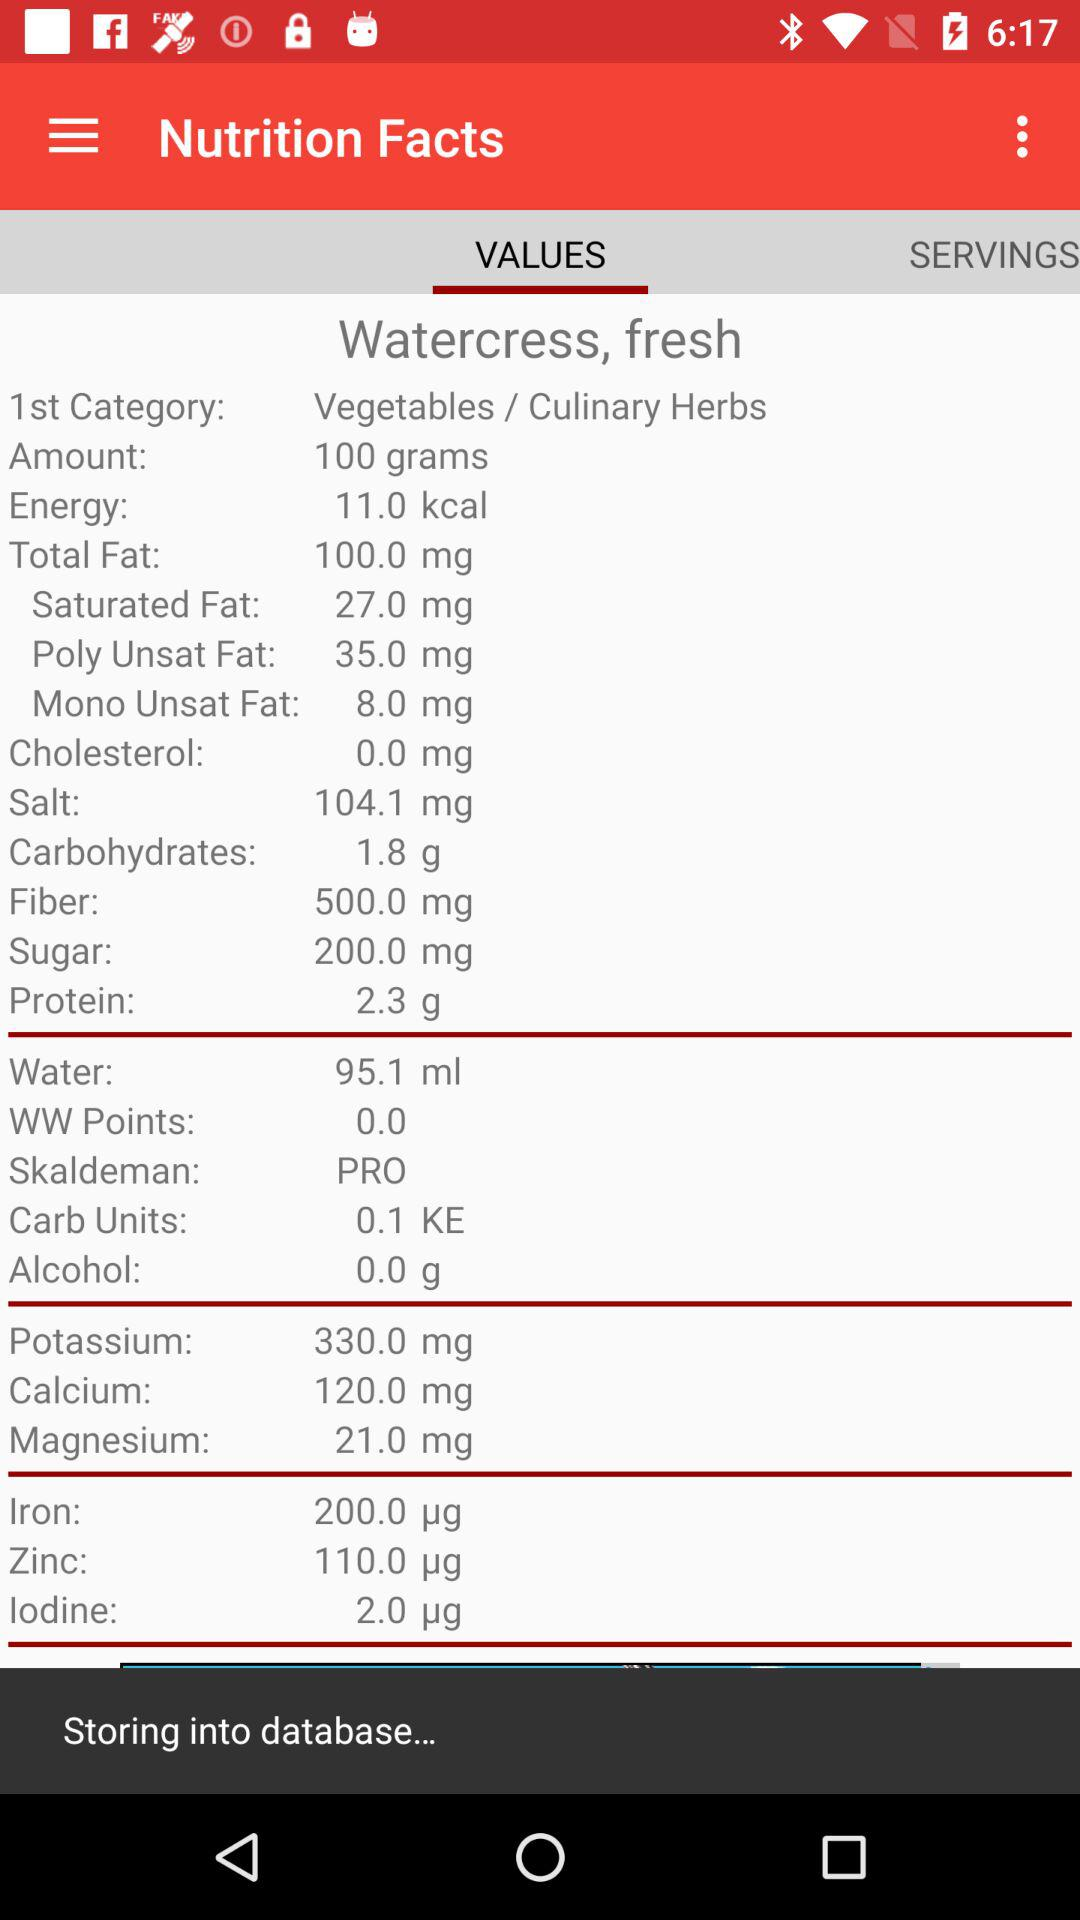What is the total amount of fat? The total amount of fat is 100.0 mg. 